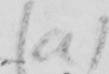What text is written in this handwritten line? ( a ) 